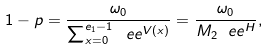Convert formula to latex. <formula><loc_0><loc_0><loc_500><loc_500>1 - p = \frac { \omega _ { 0 } } { \sum _ { x = 0 } ^ { e _ { 1 } - 1 } \ e e ^ { V ( x ) } } = \frac { \omega _ { 0 } } { M _ { 2 } \ e e ^ { H } } ,</formula> 